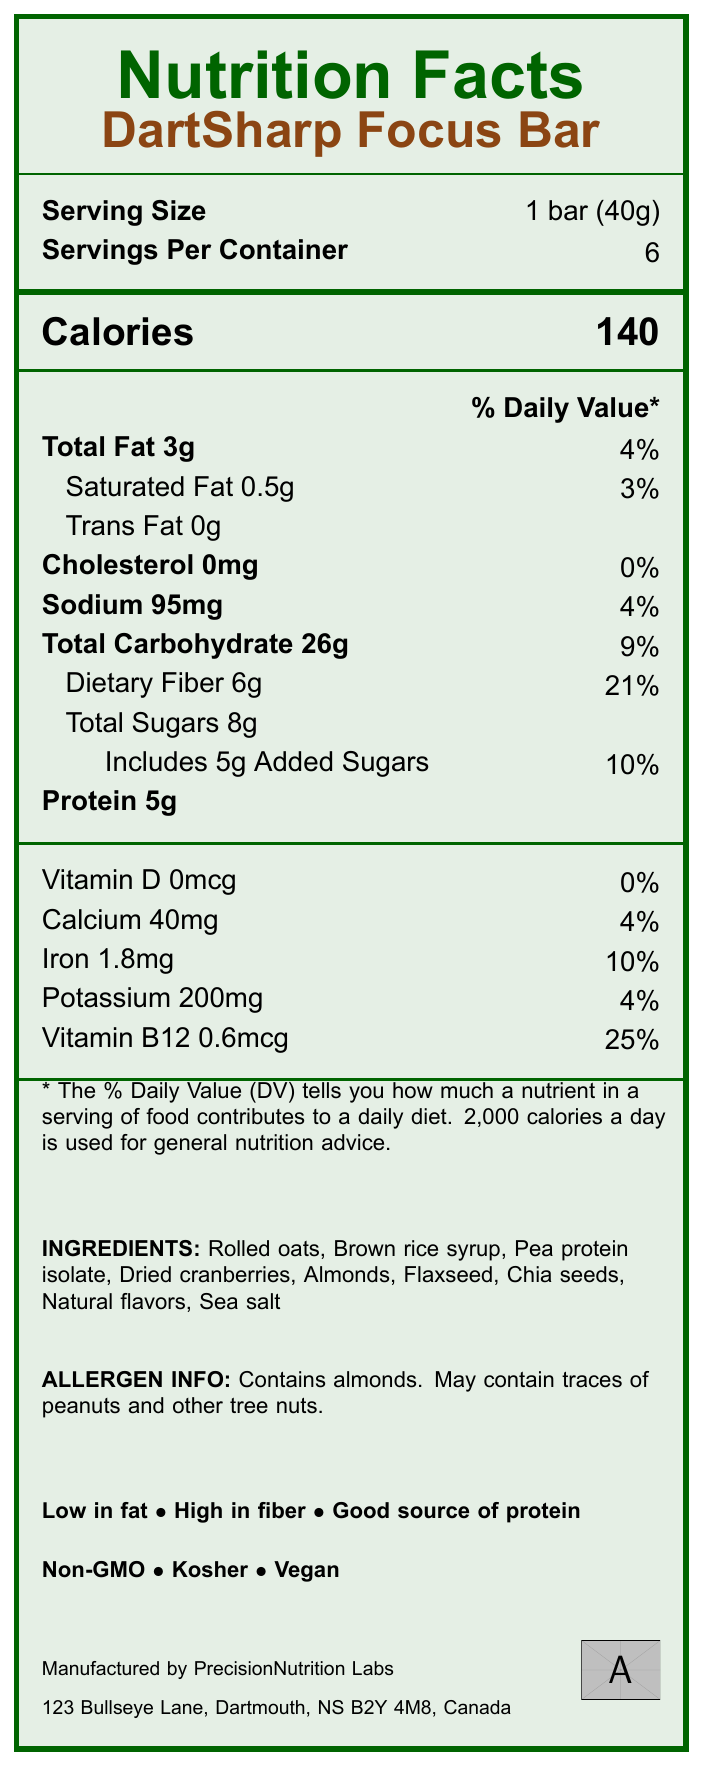what is the serving size of the DartSharp Focus Bar? The serving size is mentioned directly under the "Serving Size" section.
Answer: 1 bar (40g) how many calories are there per serving? The calories per serving is listed as 140 on the nutrition label.
Answer: 140 what is the amount of dietary fiber per serving? The dietary fiber amount is detailed under the "Dietary Fiber" section as 6g.
Answer: 6g what allergen is specifically mentioned in the DartSharp Focus Bar? The allergen information states that the bar contains almonds.
Answer: Almonds what percentage of daily vitamin B12 is provided by one serving of the DartSharp Focus Bar? The nutrition label lists a daily value percentage of 25% for Vitamin B12.
Answer: 25% how many servings are there per container of the DartSharp Focus Bar? The number of servings per container is indicated as 6.
Answer: 6 how much total fat is in one serving of the DartSharp Focus Bar? The total fat amount per serving is presented as 3g.
Answer: 3g what is the sodium content in a single serving of the DartSharp Focus Bar? The sodium content per serving is listed as 95mg.
Answer: 95mg which of the following is NOT an ingredient in the DartSharp Focus Bar? A. Brown rice syrup B. Pea protein isolate C. High fructose corn syrup D. Chia seeds The ingredient list includes Brown rice syrup, Pea protein isolate, and Chia seeds but does not mention High fructose corn syrup.
Answer: C what is the protein content per serving? A. 3g B. 4g C. 5g D. 6g The protein content per serving is documented as 5g.
Answer: C is the DartSharp Focus Bar suitable for a vegan diet? The label includes a certification that the bar is vegan.
Answer: Yes does the DartSharp Focus Bar contain any artificial preservatives? The claims and benefits section states that the bar contains no artificial preservatives.
Answer: No what are the main benefits claimed about the DartSharp Focus Bar? These points are all listed under the claims and benefits section of the label.
Answer: Low in fat, high in fiber, good source of protein, no artificial preservatives, supports mental focus, sustained energy release how much iron is in one serving of the DartSharp Focus Bar? The iron content is listed as 1.8mg per serving on the nutrition label.
Answer: 1.8mg where is the DartSharp Focus Bar manufactured? This information is detailed under the manufacturer info section of the label.
Answer: PrecisionNutrition Labs, 123 Bullseye Lane, Dartmouth, NS B2Y 4M8, Canada describe the purpose and main features of the DartSharp Focus Bar. This summary encapsulates the key points of the product's purpose, benefits, nutrient profile, certifications, and convenience as described in the document.
Answer: The DartSharp Focus Bar is designed to provide a low-fat, high-fiber snack ideal for maintaining focus during darts practice. It contains a balanced mix of nutrients, supports mental focus, and offers sustained energy release. The bar is vegan, non-GMO, and kosher. It is convenient for on-the-go snacking for both darts players and their supporters. is detailed information about the manufacturing process of DartSharp Focus Bar present? The document does not provide detailed information about the manufacturing process, only the manufacturer's address and name.
Answer: Not enough information 